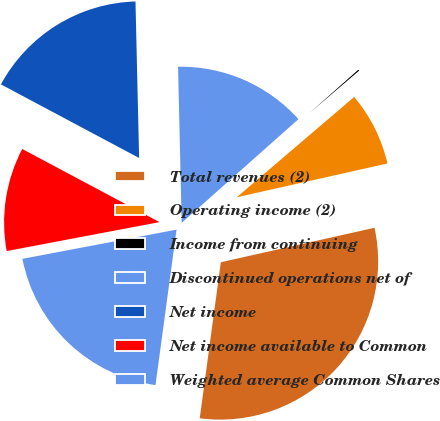Convert chart. <chart><loc_0><loc_0><loc_500><loc_500><pie_chart><fcel>Total revenues (2)<fcel>Operating income (2)<fcel>Income from continuing<fcel>Discontinued operations net of<fcel>Net income<fcel>Net income available to Common<fcel>Weighted average Common Shares<nl><fcel>30.65%<fcel>7.74%<fcel>0.31%<fcel>13.81%<fcel>16.84%<fcel>10.77%<fcel>19.88%<nl></chart> 